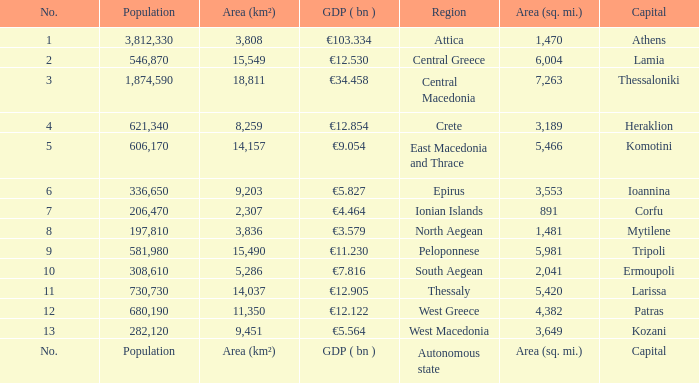What is the gdp ( bn ) where capital is capital? GDP ( bn ). 